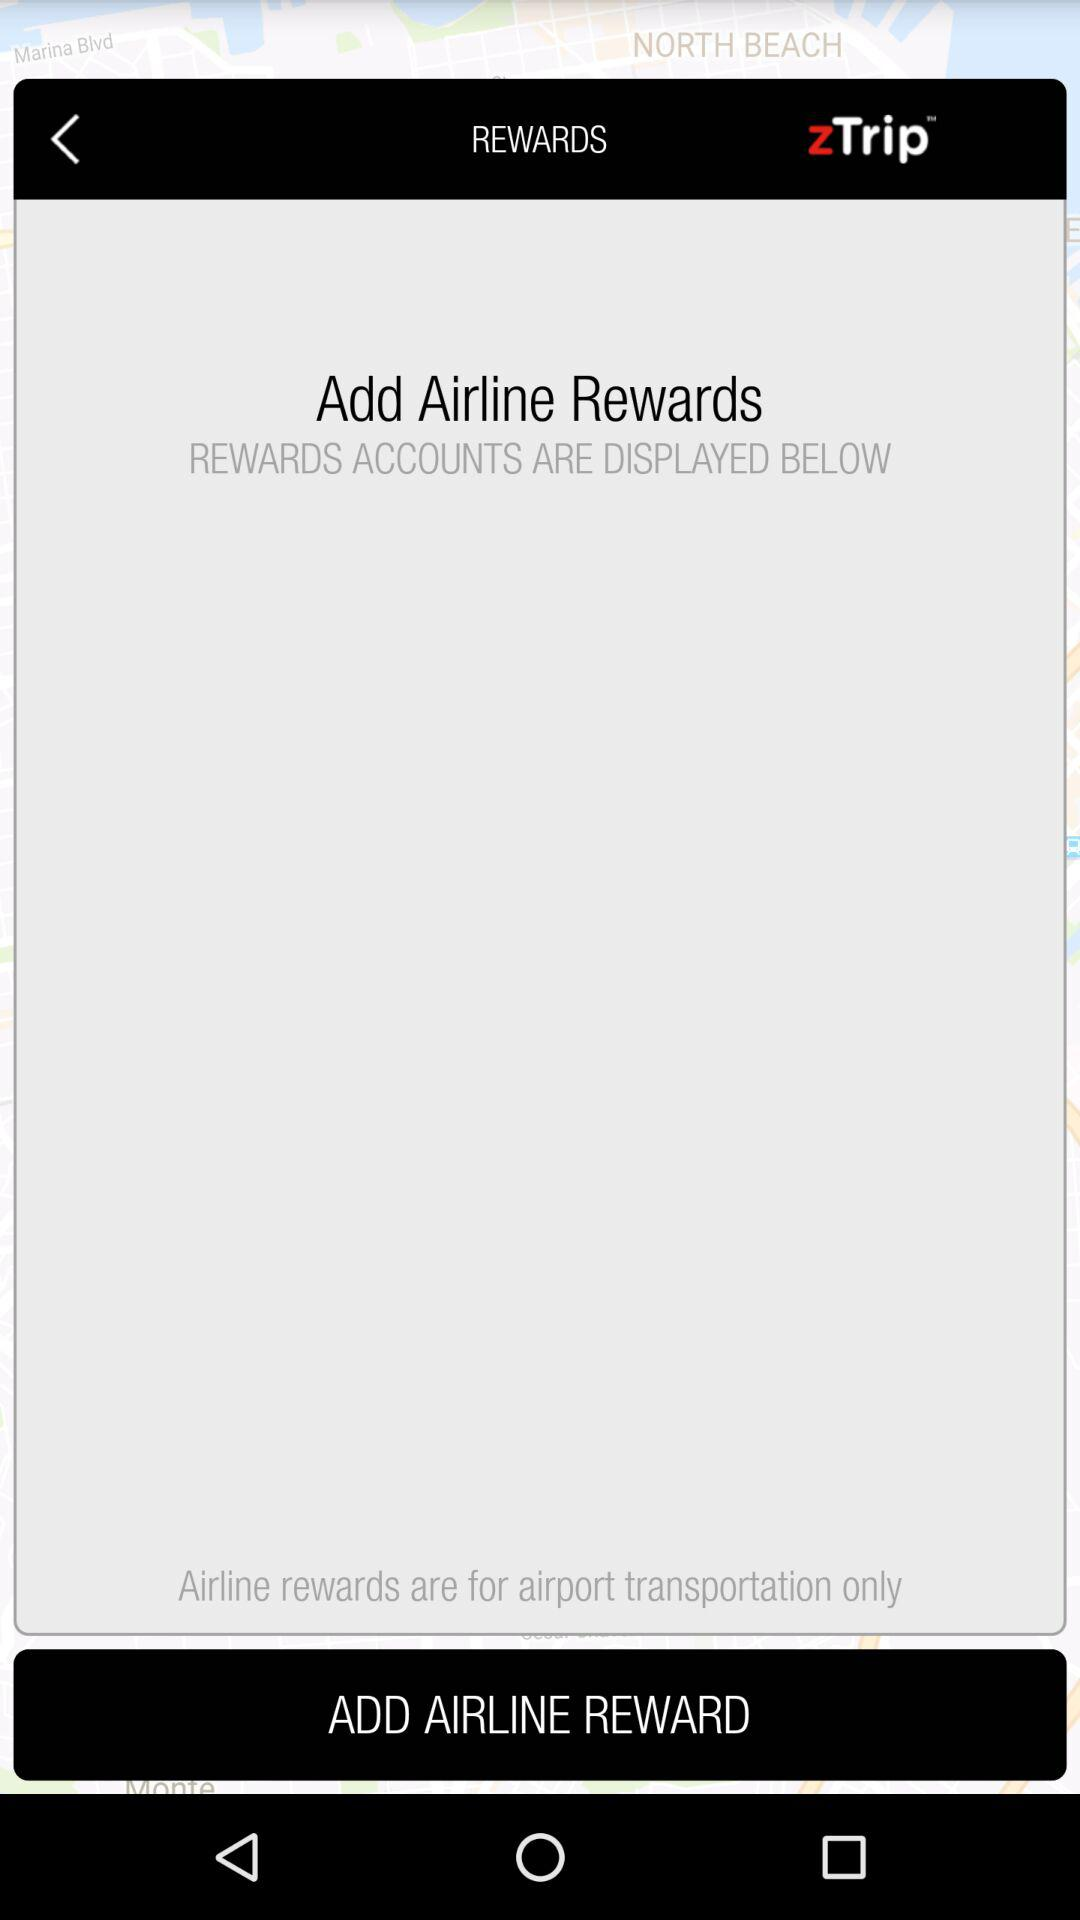What's the name of the airline facility for which airline rewards are available? The name of the airline facility for which airline rewards are available is airport transportation. 